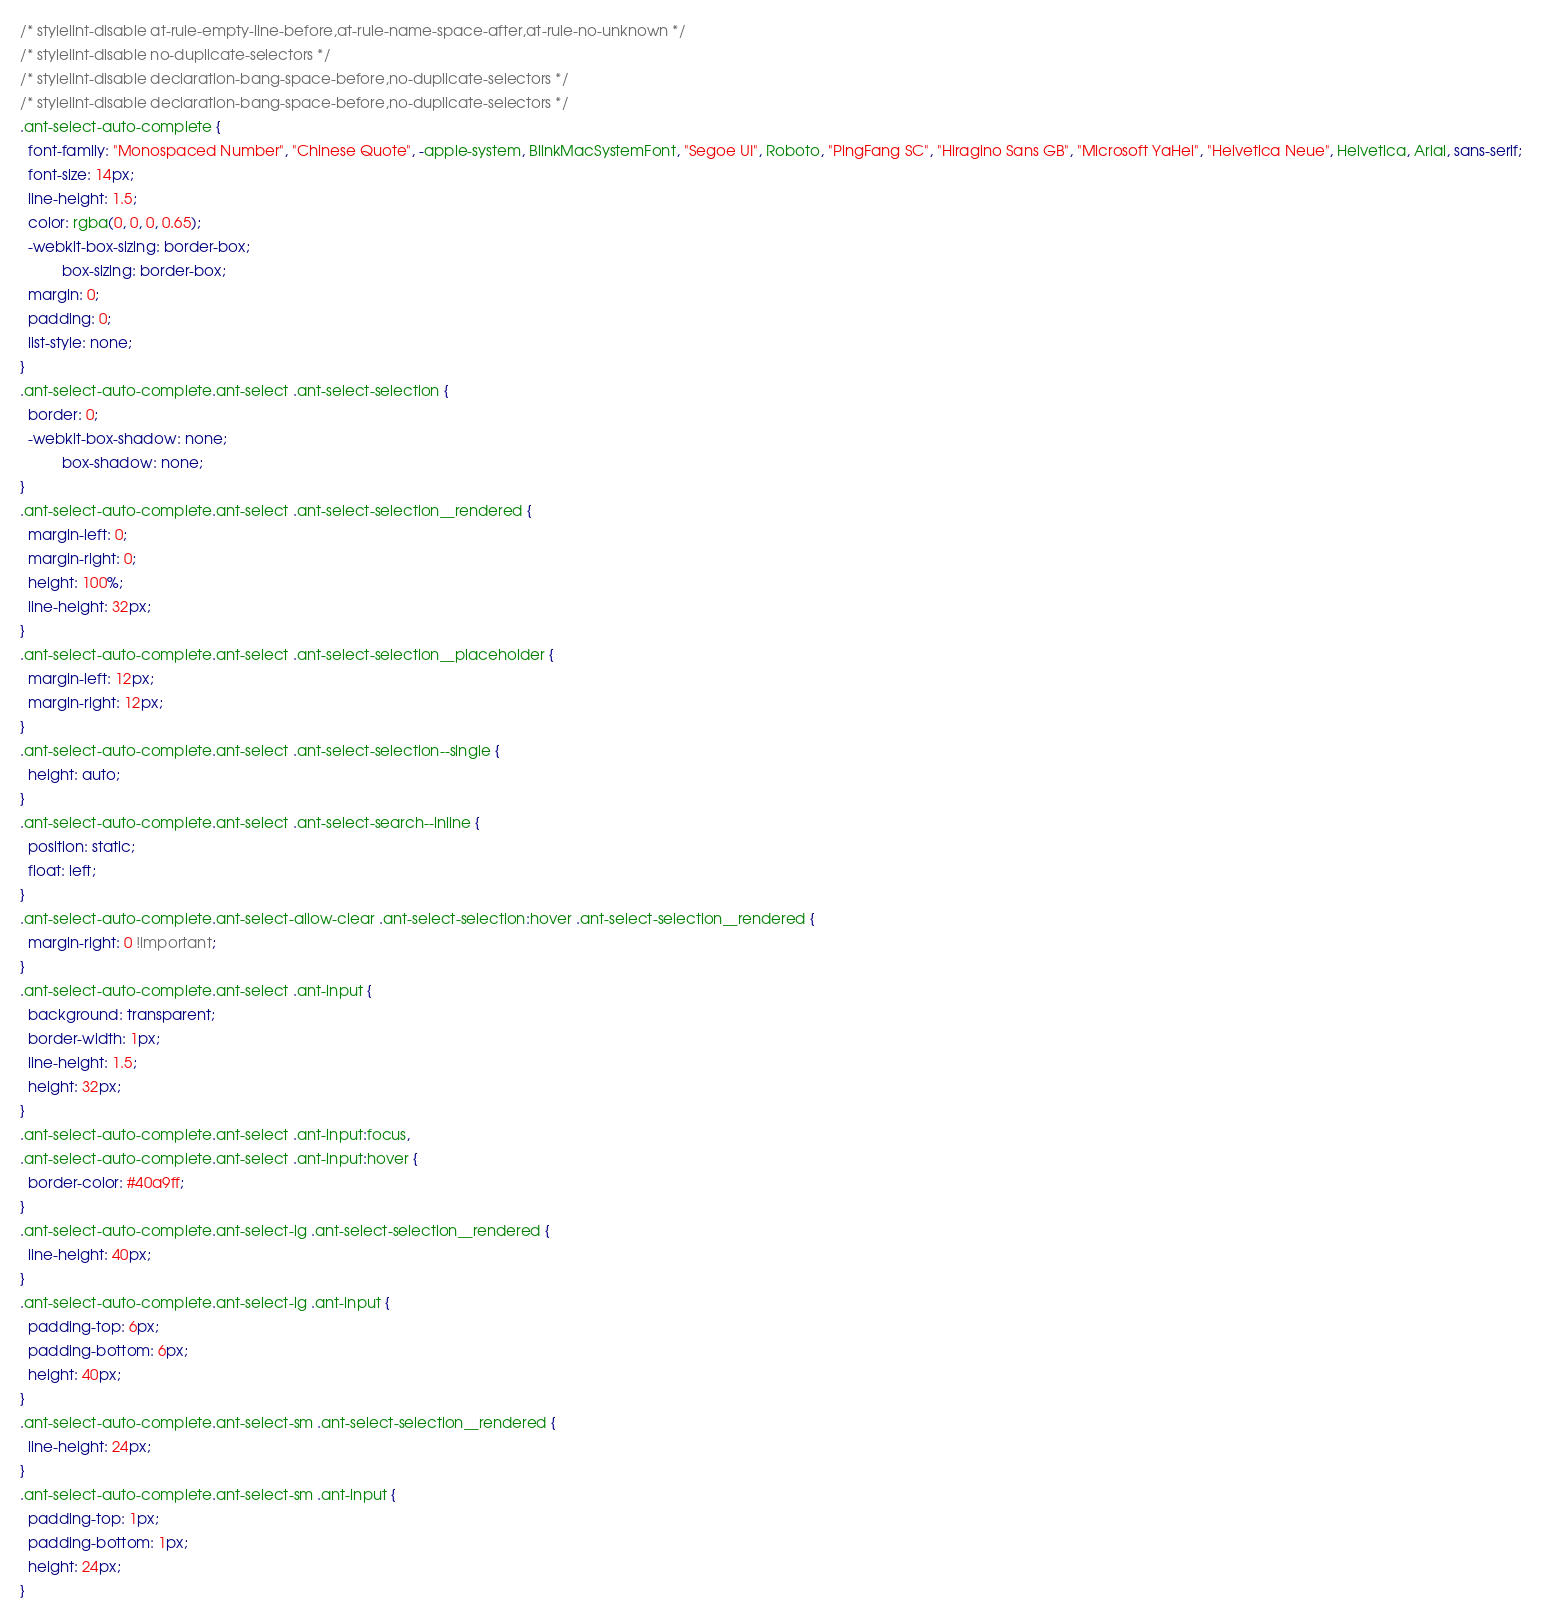<code> <loc_0><loc_0><loc_500><loc_500><_CSS_>/* stylelint-disable at-rule-empty-line-before,at-rule-name-space-after,at-rule-no-unknown */
/* stylelint-disable no-duplicate-selectors */
/* stylelint-disable declaration-bang-space-before,no-duplicate-selectors */
/* stylelint-disable declaration-bang-space-before,no-duplicate-selectors */
.ant-select-auto-complete {
  font-family: "Monospaced Number", "Chinese Quote", -apple-system, BlinkMacSystemFont, "Segoe UI", Roboto, "PingFang SC", "Hiragino Sans GB", "Microsoft YaHei", "Helvetica Neue", Helvetica, Arial, sans-serif;
  font-size: 14px;
  line-height: 1.5;
  color: rgba(0, 0, 0, 0.65);
  -webkit-box-sizing: border-box;
          box-sizing: border-box;
  margin: 0;
  padding: 0;
  list-style: none;
}
.ant-select-auto-complete.ant-select .ant-select-selection {
  border: 0;
  -webkit-box-shadow: none;
          box-shadow: none;
}
.ant-select-auto-complete.ant-select .ant-select-selection__rendered {
  margin-left: 0;
  margin-right: 0;
  height: 100%;
  line-height: 32px;
}
.ant-select-auto-complete.ant-select .ant-select-selection__placeholder {
  margin-left: 12px;
  margin-right: 12px;
}
.ant-select-auto-complete.ant-select .ant-select-selection--single {
  height: auto;
}
.ant-select-auto-complete.ant-select .ant-select-search--inline {
  position: static;
  float: left;
}
.ant-select-auto-complete.ant-select-allow-clear .ant-select-selection:hover .ant-select-selection__rendered {
  margin-right: 0 !important;
}
.ant-select-auto-complete.ant-select .ant-input {
  background: transparent;
  border-width: 1px;
  line-height: 1.5;
  height: 32px;
}
.ant-select-auto-complete.ant-select .ant-input:focus,
.ant-select-auto-complete.ant-select .ant-input:hover {
  border-color: #40a9ff;
}
.ant-select-auto-complete.ant-select-lg .ant-select-selection__rendered {
  line-height: 40px;
}
.ant-select-auto-complete.ant-select-lg .ant-input {
  padding-top: 6px;
  padding-bottom: 6px;
  height: 40px;
}
.ant-select-auto-complete.ant-select-sm .ant-select-selection__rendered {
  line-height: 24px;
}
.ant-select-auto-complete.ant-select-sm .ant-input {
  padding-top: 1px;
  padding-bottom: 1px;
  height: 24px;
}
</code> 